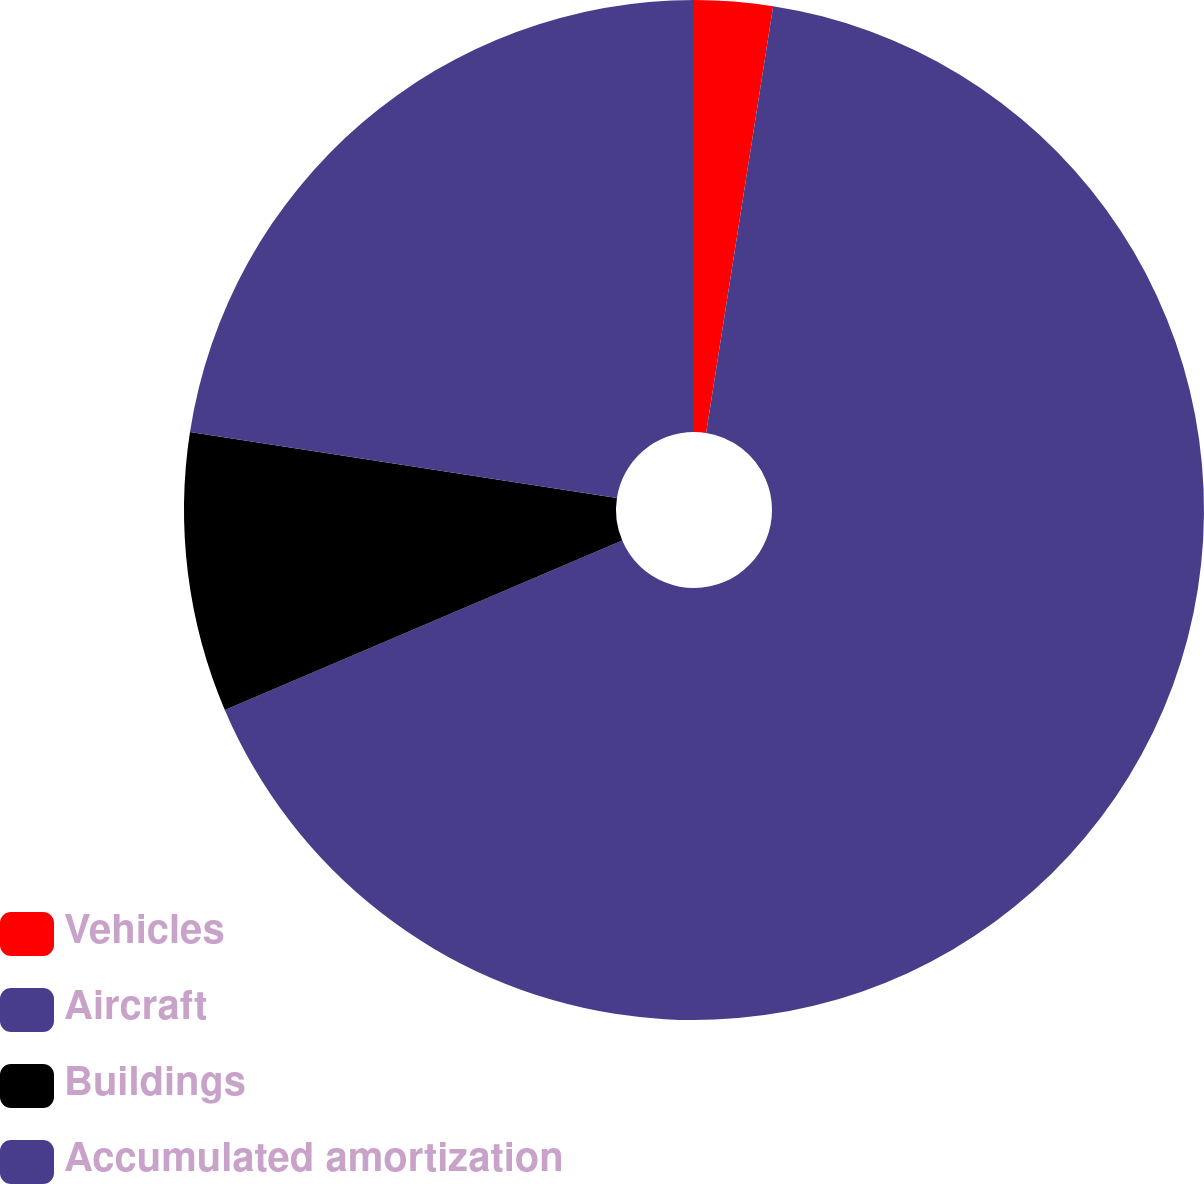<chart> <loc_0><loc_0><loc_500><loc_500><pie_chart><fcel>Vehicles<fcel>Aircraft<fcel>Buildings<fcel>Accumulated amortization<nl><fcel>2.48%<fcel>66.11%<fcel>8.85%<fcel>22.56%<nl></chart> 